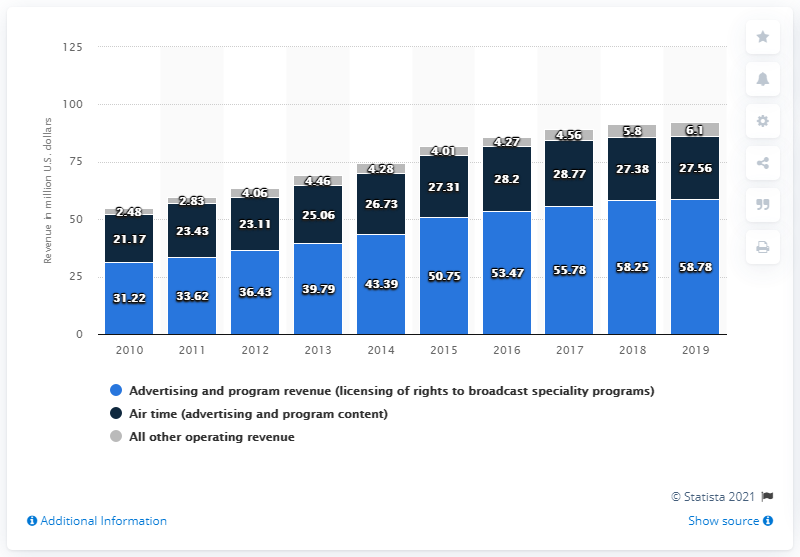Can you tell me how the revenue for advertising and program content has changed over the years? The revenue for advertising and program content shows a general upward trend from 2010 to 2019, starting at approximately 21.17 million U.S. dollars in 2010 and reaching about 27.56 million in 2019. 